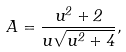Convert formula to latex. <formula><loc_0><loc_0><loc_500><loc_500>A = \frac { u ^ { 2 } + 2 } { u \sqrt { u ^ { 2 } + 4 } } ,</formula> 